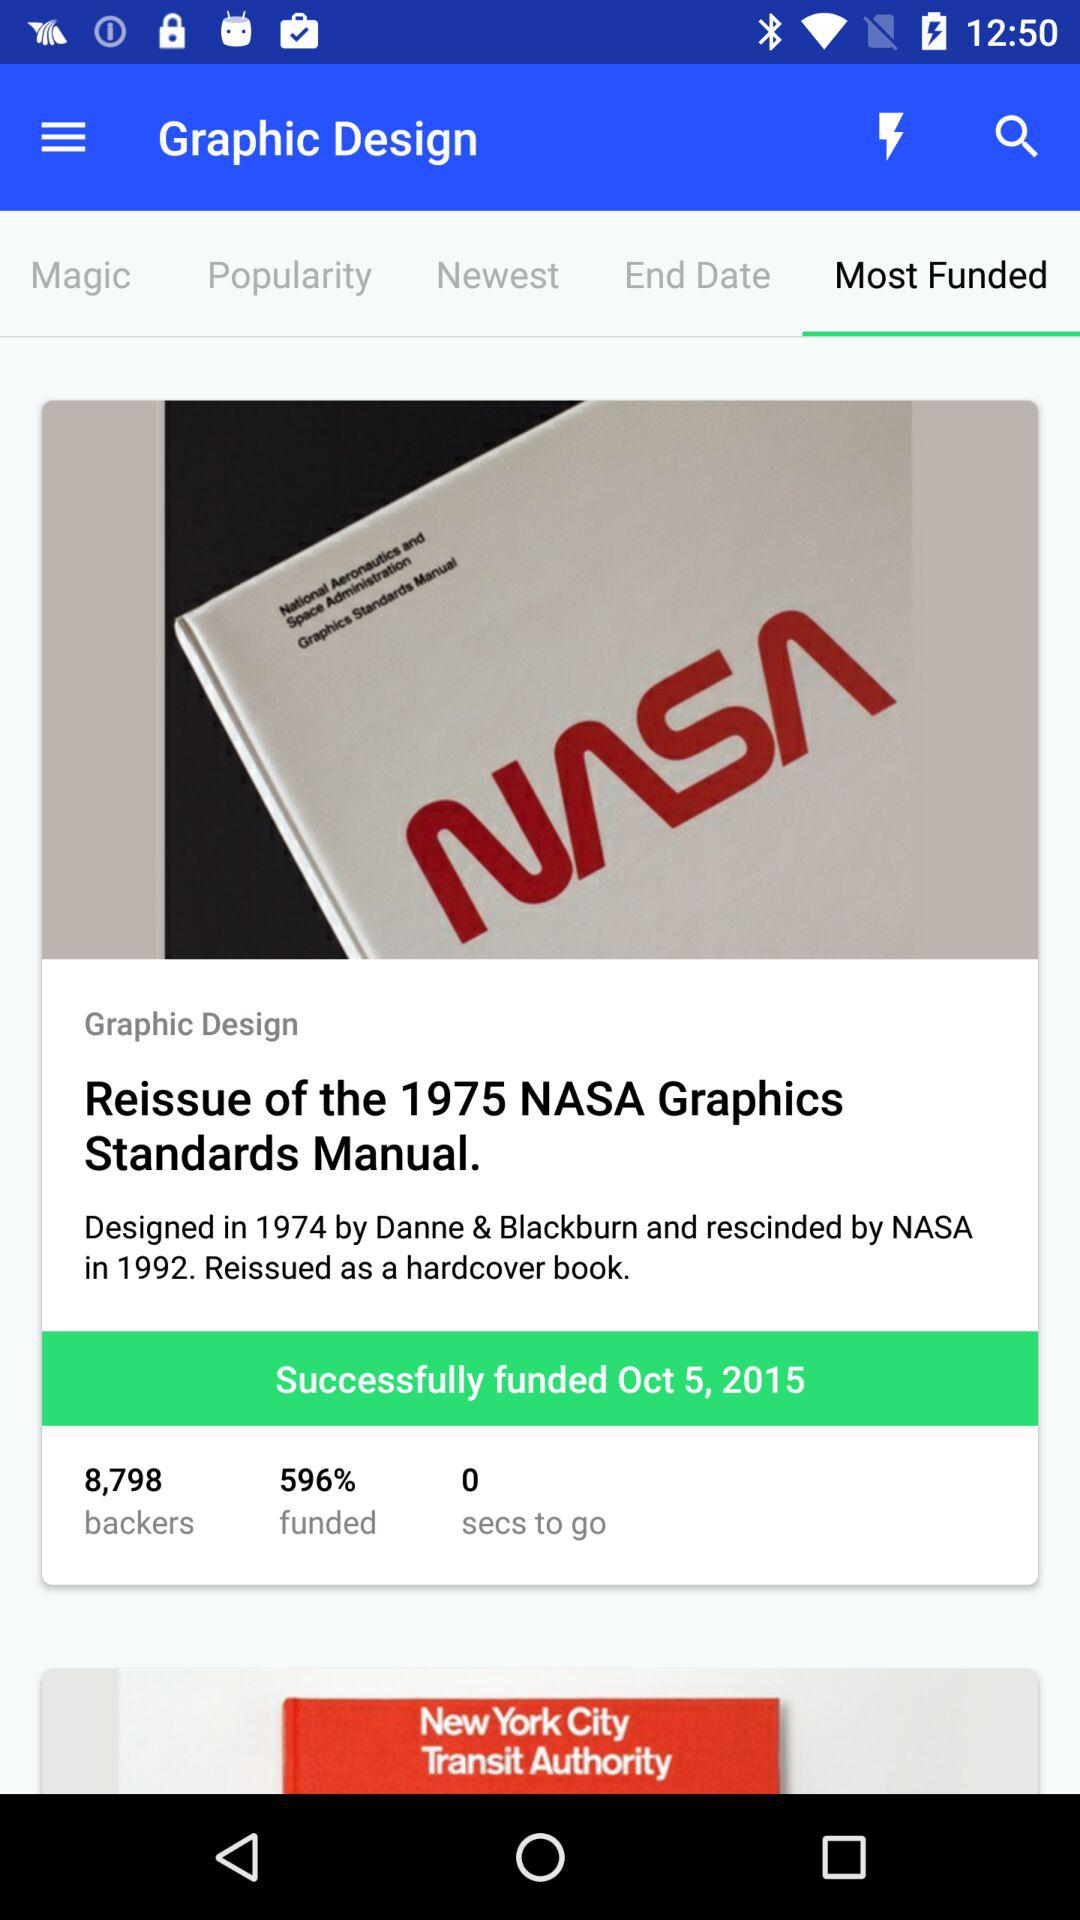Who is the designer of the 1975 NASA Graphics Standards Manual? The designers are Danne & Blackburn. 